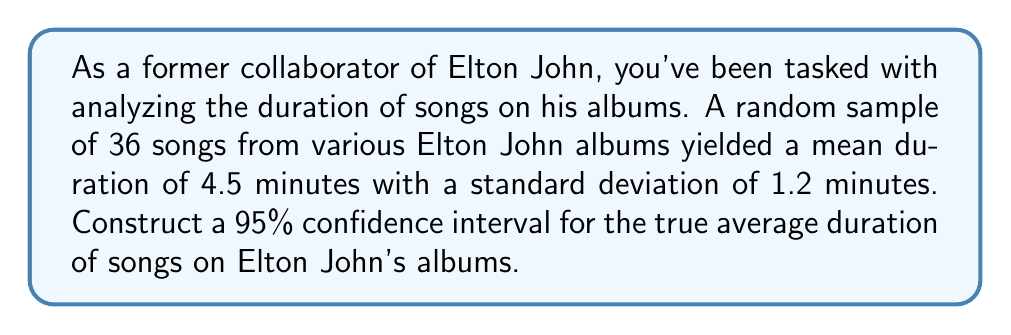Teach me how to tackle this problem. Let's approach this step-by-step:

1) We're dealing with a confidence interval for a population mean when the population standard deviation is unknown. We'll use the t-distribution.

2) Given information:
   - Sample size: $n = 36$
   - Sample mean: $\bar{x} = 4.5$ minutes
   - Sample standard deviation: $s = 1.2$ minutes
   - Confidence level: 95% (α = 0.05)

3) The formula for the confidence interval is:

   $$\bar{x} \pm t_{\alpha/2, n-1} \cdot \frac{s}{\sqrt{n}}$$

4) We need to find $t_{\alpha/2, n-1}$:
   - Degrees of freedom: $df = n - 1 = 35$
   - For a 95% confidence interval, $\alpha/2 = 0.025$
   - From t-table or calculator: $t_{0.025, 35} \approx 2.030$

5) Now, let's calculate the margin of error:

   $$\text{Margin of Error} = t_{\alpha/2, n-1} \cdot \frac{s}{\sqrt{n}} = 2.030 \cdot \frac{1.2}{\sqrt{36}} \approx 0.406$$

6) Finally, we can construct the confidence interval:

   $$4.5 \pm 0.406$$

   Lower bound: $4.5 - 0.406 = 4.094$
   Upper bound: $4.5 + 0.406 = 4.906$

Therefore, we are 95% confident that the true average duration of songs on Elton John's albums is between 4.094 and 4.906 minutes.
Answer: (4.094, 4.906) minutes 